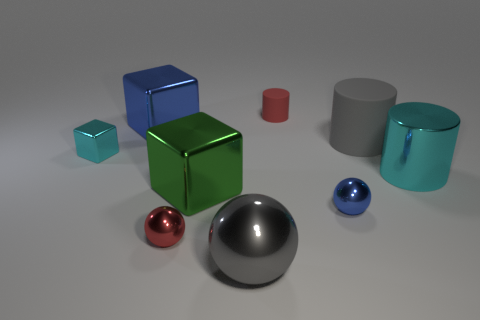Subtract 1 cylinders. How many cylinders are left? 2 Add 1 large green blocks. How many objects exist? 10 Subtract all small red metal cylinders. Subtract all big metal balls. How many objects are left? 8 Add 7 gray cylinders. How many gray cylinders are left? 8 Add 1 small balls. How many small balls exist? 3 Subtract 1 blue balls. How many objects are left? 8 Subtract all balls. How many objects are left? 6 